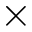<formula> <loc_0><loc_0><loc_500><loc_500>\times</formula> 